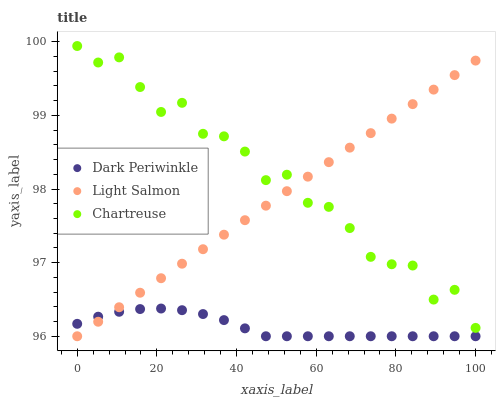Does Dark Periwinkle have the minimum area under the curve?
Answer yes or no. Yes. Does Chartreuse have the maximum area under the curve?
Answer yes or no. Yes. Does Chartreuse have the minimum area under the curve?
Answer yes or no. No. Does Dark Periwinkle have the maximum area under the curve?
Answer yes or no. No. Is Light Salmon the smoothest?
Answer yes or no. Yes. Is Chartreuse the roughest?
Answer yes or no. Yes. Is Dark Periwinkle the smoothest?
Answer yes or no. No. Is Dark Periwinkle the roughest?
Answer yes or no. No. Does Light Salmon have the lowest value?
Answer yes or no. Yes. Does Chartreuse have the lowest value?
Answer yes or no. No. Does Chartreuse have the highest value?
Answer yes or no. Yes. Does Dark Periwinkle have the highest value?
Answer yes or no. No. Is Dark Periwinkle less than Chartreuse?
Answer yes or no. Yes. Is Chartreuse greater than Dark Periwinkle?
Answer yes or no. Yes. Does Light Salmon intersect Dark Periwinkle?
Answer yes or no. Yes. Is Light Salmon less than Dark Periwinkle?
Answer yes or no. No. Is Light Salmon greater than Dark Periwinkle?
Answer yes or no. No. Does Dark Periwinkle intersect Chartreuse?
Answer yes or no. No. 